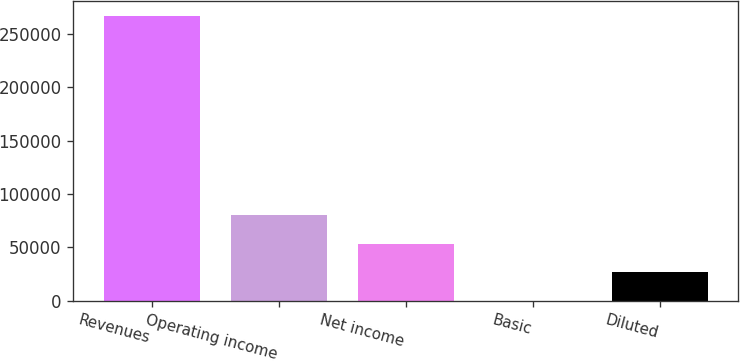<chart> <loc_0><loc_0><loc_500><loc_500><bar_chart><fcel>Revenues<fcel>Operating income<fcel>Net income<fcel>Basic<fcel>Diluted<nl><fcel>267469<fcel>80240.9<fcel>53494<fcel>0.21<fcel>26747.1<nl></chart> 